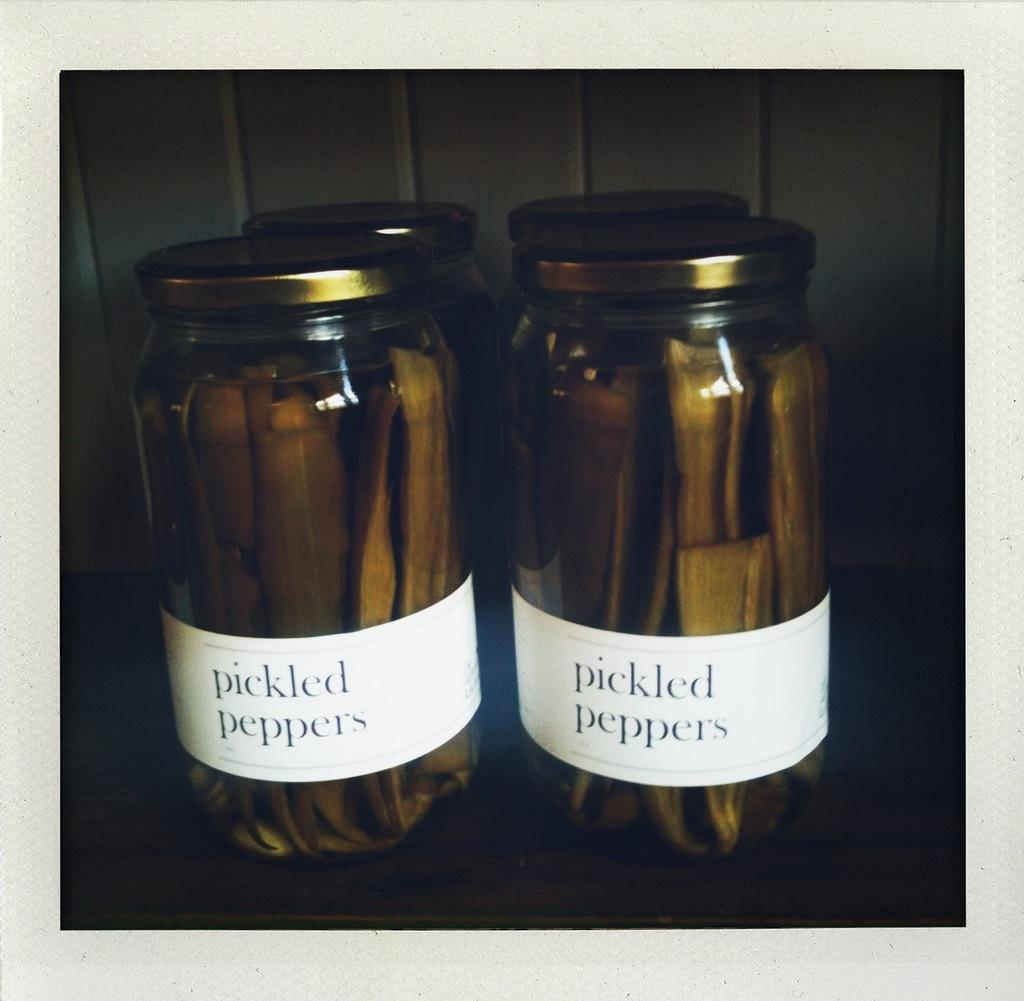Provide a one-sentence caption for the provided image. Two jars sitting on a counter with a small white label that reads pickled peppers. 